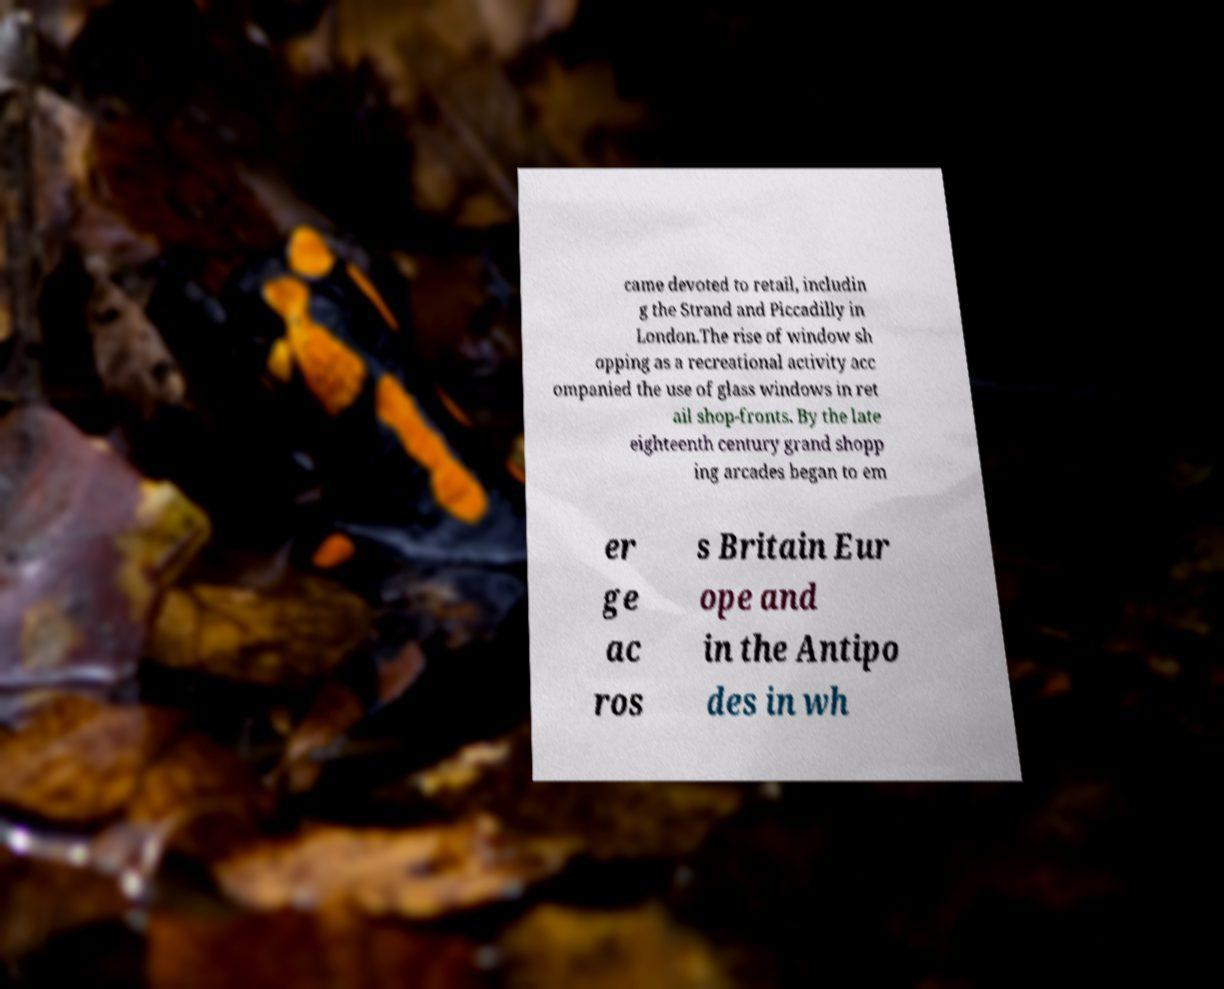Please identify and transcribe the text found in this image. came devoted to retail, includin g the Strand and Piccadilly in London.The rise of window sh opping as a recreational activity acc ompanied the use of glass windows in ret ail shop-fronts. By the late eighteenth century grand shopp ing arcades began to em er ge ac ros s Britain Eur ope and in the Antipo des in wh 